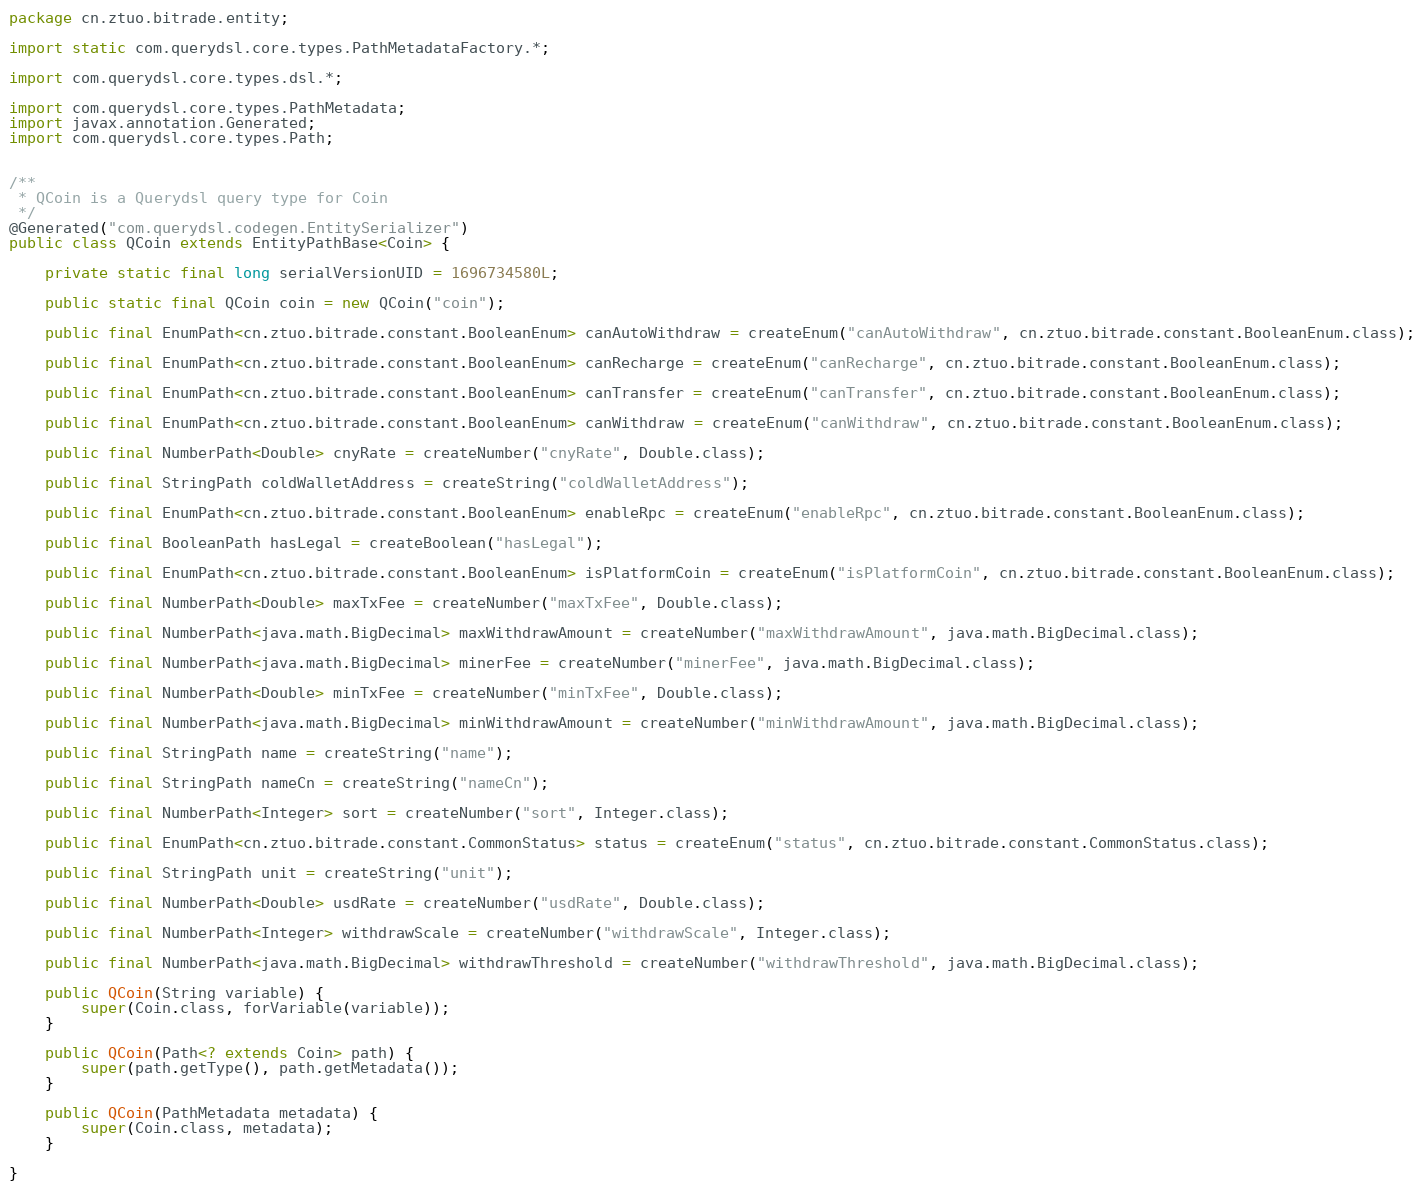Convert code to text. <code><loc_0><loc_0><loc_500><loc_500><_Java_>package cn.ztuo.bitrade.entity;

import static com.querydsl.core.types.PathMetadataFactory.*;

import com.querydsl.core.types.dsl.*;

import com.querydsl.core.types.PathMetadata;
import javax.annotation.Generated;
import com.querydsl.core.types.Path;


/**
 * QCoin is a Querydsl query type for Coin
 */
@Generated("com.querydsl.codegen.EntitySerializer")
public class QCoin extends EntityPathBase<Coin> {

    private static final long serialVersionUID = 1696734580L;

    public static final QCoin coin = new QCoin("coin");

    public final EnumPath<cn.ztuo.bitrade.constant.BooleanEnum> canAutoWithdraw = createEnum("canAutoWithdraw", cn.ztuo.bitrade.constant.BooleanEnum.class);

    public final EnumPath<cn.ztuo.bitrade.constant.BooleanEnum> canRecharge = createEnum("canRecharge", cn.ztuo.bitrade.constant.BooleanEnum.class);

    public final EnumPath<cn.ztuo.bitrade.constant.BooleanEnum> canTransfer = createEnum("canTransfer", cn.ztuo.bitrade.constant.BooleanEnum.class);

    public final EnumPath<cn.ztuo.bitrade.constant.BooleanEnum> canWithdraw = createEnum("canWithdraw", cn.ztuo.bitrade.constant.BooleanEnum.class);

    public final NumberPath<Double> cnyRate = createNumber("cnyRate", Double.class);

    public final StringPath coldWalletAddress = createString("coldWalletAddress");

    public final EnumPath<cn.ztuo.bitrade.constant.BooleanEnum> enableRpc = createEnum("enableRpc", cn.ztuo.bitrade.constant.BooleanEnum.class);

    public final BooleanPath hasLegal = createBoolean("hasLegal");

    public final EnumPath<cn.ztuo.bitrade.constant.BooleanEnum> isPlatformCoin = createEnum("isPlatformCoin", cn.ztuo.bitrade.constant.BooleanEnum.class);

    public final NumberPath<Double> maxTxFee = createNumber("maxTxFee", Double.class);

    public final NumberPath<java.math.BigDecimal> maxWithdrawAmount = createNumber("maxWithdrawAmount", java.math.BigDecimal.class);

    public final NumberPath<java.math.BigDecimal> minerFee = createNumber("minerFee", java.math.BigDecimal.class);

    public final NumberPath<Double> minTxFee = createNumber("minTxFee", Double.class);

    public final NumberPath<java.math.BigDecimal> minWithdrawAmount = createNumber("minWithdrawAmount", java.math.BigDecimal.class);

    public final StringPath name = createString("name");

    public final StringPath nameCn = createString("nameCn");

    public final NumberPath<Integer> sort = createNumber("sort", Integer.class);

    public final EnumPath<cn.ztuo.bitrade.constant.CommonStatus> status = createEnum("status", cn.ztuo.bitrade.constant.CommonStatus.class);

    public final StringPath unit = createString("unit");

    public final NumberPath<Double> usdRate = createNumber("usdRate", Double.class);

    public final NumberPath<Integer> withdrawScale = createNumber("withdrawScale", Integer.class);

    public final NumberPath<java.math.BigDecimal> withdrawThreshold = createNumber("withdrawThreshold", java.math.BigDecimal.class);

    public QCoin(String variable) {
        super(Coin.class, forVariable(variable));
    }

    public QCoin(Path<? extends Coin> path) {
        super(path.getType(), path.getMetadata());
    }

    public QCoin(PathMetadata metadata) {
        super(Coin.class, metadata);
    }

}

</code> 